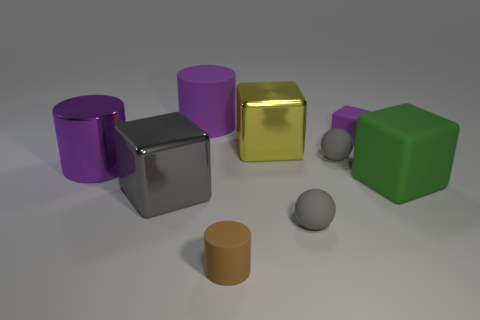Are there more gray balls than small gray cubes?
Your answer should be compact. Yes. What is the size of the purple cylinder on the right side of the purple cylinder in front of the purple cylinder behind the large yellow metal cube?
Your answer should be compact. Large. How big is the cylinder that is on the left side of the large gray block?
Provide a short and direct response. Large. How many objects are green things or cubes that are left of the small purple matte thing?
Give a very brief answer. 3. What number of other things are the same size as the yellow block?
Keep it short and to the point. 4. What material is the gray object that is the same shape as the small purple rubber object?
Offer a very short reply. Metal. Is the number of large gray objects on the left side of the large gray block greater than the number of big blue spheres?
Your answer should be compact. No. Is there any other thing of the same color as the large metal cylinder?
Offer a very short reply. Yes. What is the shape of the gray thing that is made of the same material as the big yellow thing?
Ensure brevity in your answer.  Cube. Is the large purple thing that is behind the large yellow shiny object made of the same material as the tiny cylinder?
Your response must be concise. Yes. 